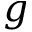Convert formula to latex. <formula><loc_0><loc_0><loc_500><loc_500>g</formula> 